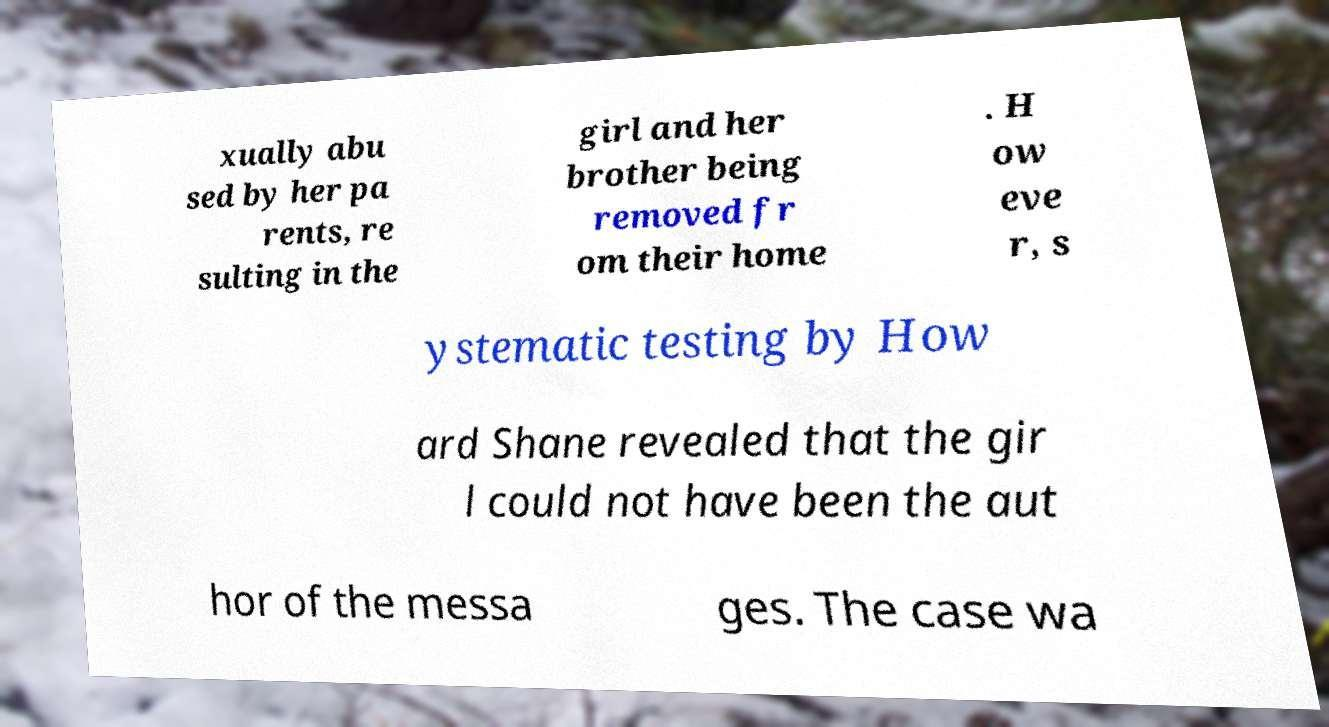Please identify and transcribe the text found in this image. xually abu sed by her pa rents, re sulting in the girl and her brother being removed fr om their home . H ow eve r, s ystematic testing by How ard Shane revealed that the gir l could not have been the aut hor of the messa ges. The case wa 